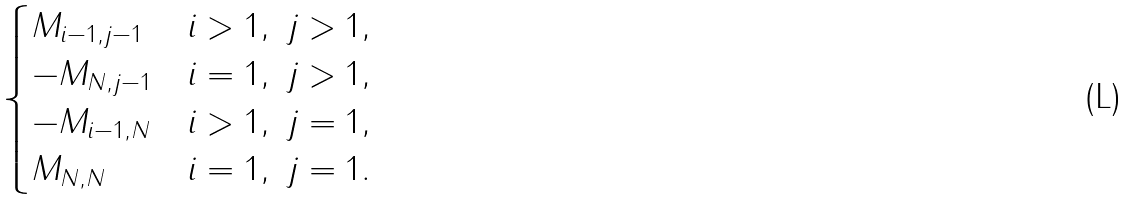Convert formula to latex. <formula><loc_0><loc_0><loc_500><loc_500>\begin{cases} M _ { i - 1 , j - 1 } & i > 1 , \ j > 1 , \\ - M _ { N , j - 1 } & i = 1 , \ j > 1 , \\ - M _ { i - 1 , N } & i > 1 , \ j = 1 , \\ M _ { N , N } & i = 1 , \ j = 1 . \end{cases}</formula> 